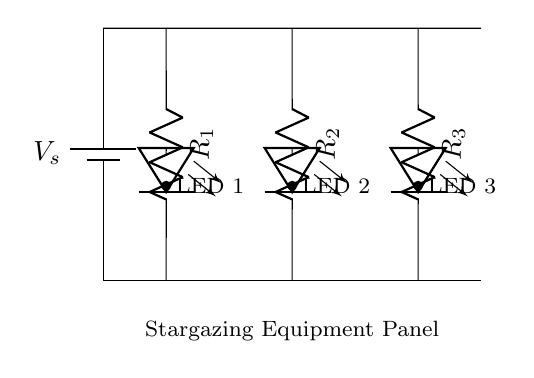What is the symbol used for the power source? The symbol used for the power source is a battery symbol, which is represented by two vertical lines of differing lengths. The longer line indicates the positive terminal.
Answer: battery How many resistors are in the circuit? There are three resistors in total, each connected to different LED indicators in the parallel configuration.
Answer: three What type of circuit is represented? The circuit is a parallel circuit, as it shows multiple paths for current to flow to the LED indicators independently.
Answer: parallel What is the purpose of resistors in this circuit? The purpose of resistors is to limit the current flowing through each LED, protecting them from excess current that could damage them.
Answer: limit current If LED 1 is turned on, what happens to LED 2? If LED 1 is turned on, LED 2 will also turn on because the circuit is parallel, allowing independent operation of the LEDs.
Answer: LED 2 also turns on What happens to the total current when more LEDs are added? When more LEDs are added to the circuit, the total current will increase because each added LED provides another path for the current to flow through.
Answer: total current increases What is the significance of connecting LEDs in parallel for stargazing equipment? Connecting LEDs in parallel allows for independent control and operation of each LED, ensuring reliability and functionality in stargazing equipment.
Answer: reliability and functionality 